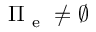<formula> <loc_0><loc_0><loc_500><loc_500>\Pi _ { e } \neq \emptyset</formula> 